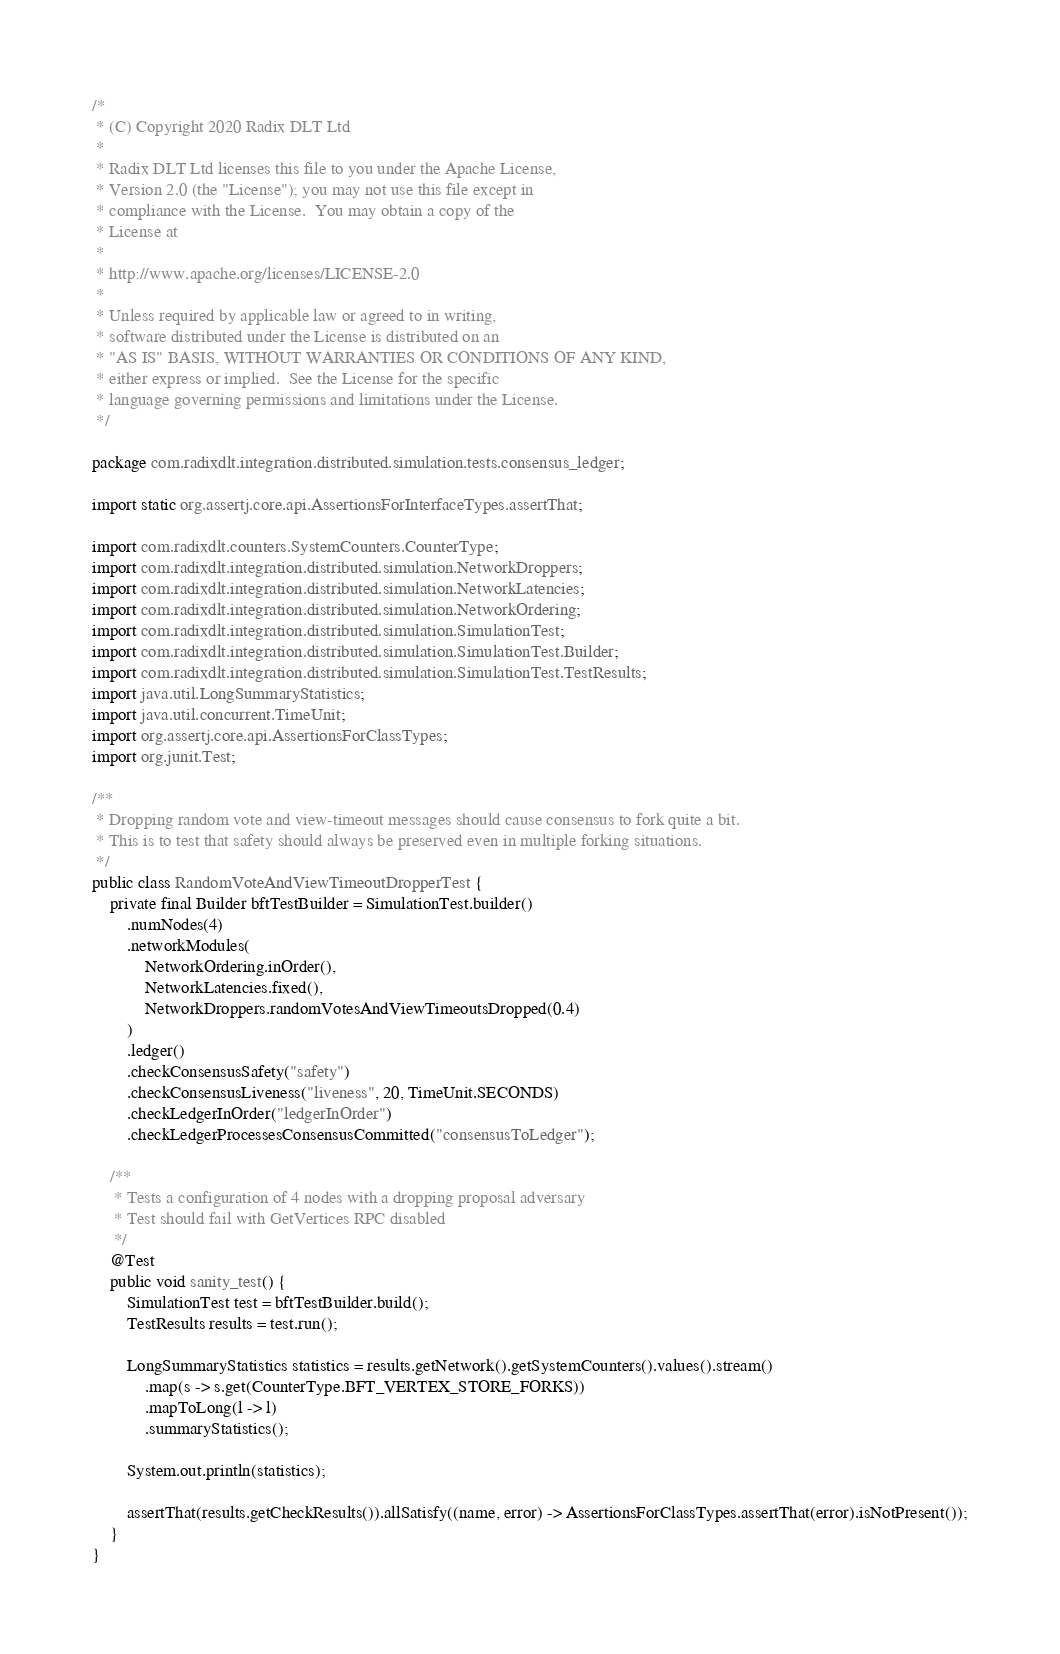<code> <loc_0><loc_0><loc_500><loc_500><_Java_>/*
 * (C) Copyright 2020 Radix DLT Ltd
 *
 * Radix DLT Ltd licenses this file to you under the Apache License,
 * Version 2.0 (the "License"); you may not use this file except in
 * compliance with the License.  You may obtain a copy of the
 * License at
 *
 * http://www.apache.org/licenses/LICENSE-2.0
 *
 * Unless required by applicable law or agreed to in writing,
 * software distributed under the License is distributed on an
 * "AS IS" BASIS, WITHOUT WARRANTIES OR CONDITIONS OF ANY KIND,
 * either express or implied.  See the License for the specific
 * language governing permissions and limitations under the License.
 */

package com.radixdlt.integration.distributed.simulation.tests.consensus_ledger;

import static org.assertj.core.api.AssertionsForInterfaceTypes.assertThat;

import com.radixdlt.counters.SystemCounters.CounterType;
import com.radixdlt.integration.distributed.simulation.NetworkDroppers;
import com.radixdlt.integration.distributed.simulation.NetworkLatencies;
import com.radixdlt.integration.distributed.simulation.NetworkOrdering;
import com.radixdlt.integration.distributed.simulation.SimulationTest;
import com.radixdlt.integration.distributed.simulation.SimulationTest.Builder;
import com.radixdlt.integration.distributed.simulation.SimulationTest.TestResults;
import java.util.LongSummaryStatistics;
import java.util.concurrent.TimeUnit;
import org.assertj.core.api.AssertionsForClassTypes;
import org.junit.Test;

/**
 * Dropping random vote and view-timeout messages should cause consensus to fork quite a bit.
 * This is to test that safety should always be preserved even in multiple forking situations.
 */
public class RandomVoteAndViewTimeoutDropperTest {
	private final Builder bftTestBuilder = SimulationTest.builder()
		.numNodes(4)
		.networkModules(
			NetworkOrdering.inOrder(),
			NetworkLatencies.fixed(),
			NetworkDroppers.randomVotesAndViewTimeoutsDropped(0.4)
		)
		.ledger()
		.checkConsensusSafety("safety")
		.checkConsensusLiveness("liveness", 20, TimeUnit.SECONDS)
		.checkLedgerInOrder("ledgerInOrder")
		.checkLedgerProcessesConsensusCommitted("consensusToLedger");

	/**
	 * Tests a configuration of 4 nodes with a dropping proposal adversary
	 * Test should fail with GetVertices RPC disabled
	 */
	@Test
	public void sanity_test() {
		SimulationTest test = bftTestBuilder.build();
		TestResults results = test.run();

		LongSummaryStatistics statistics = results.getNetwork().getSystemCounters().values().stream()
			.map(s -> s.get(CounterType.BFT_VERTEX_STORE_FORKS))
			.mapToLong(l -> l)
			.summaryStatistics();

		System.out.println(statistics);

		assertThat(results.getCheckResults()).allSatisfy((name, error) -> AssertionsForClassTypes.assertThat(error).isNotPresent());
	}
}
</code> 